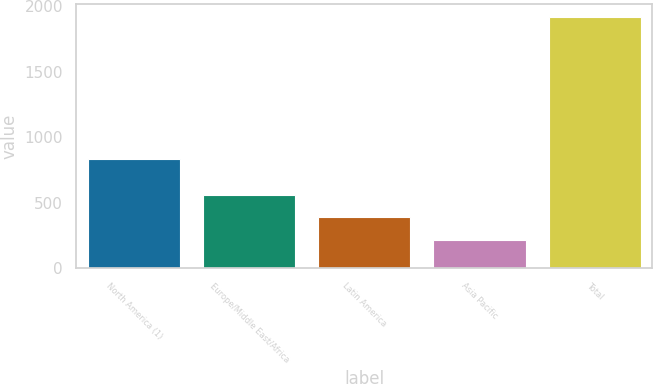<chart> <loc_0><loc_0><loc_500><loc_500><bar_chart><fcel>North America (1)<fcel>Europe/Middle East/Africa<fcel>Latin America<fcel>Asia Pacific<fcel>Total<nl><fcel>834.8<fcel>559.9<fcel>388.16<fcel>217.8<fcel>1921.4<nl></chart> 